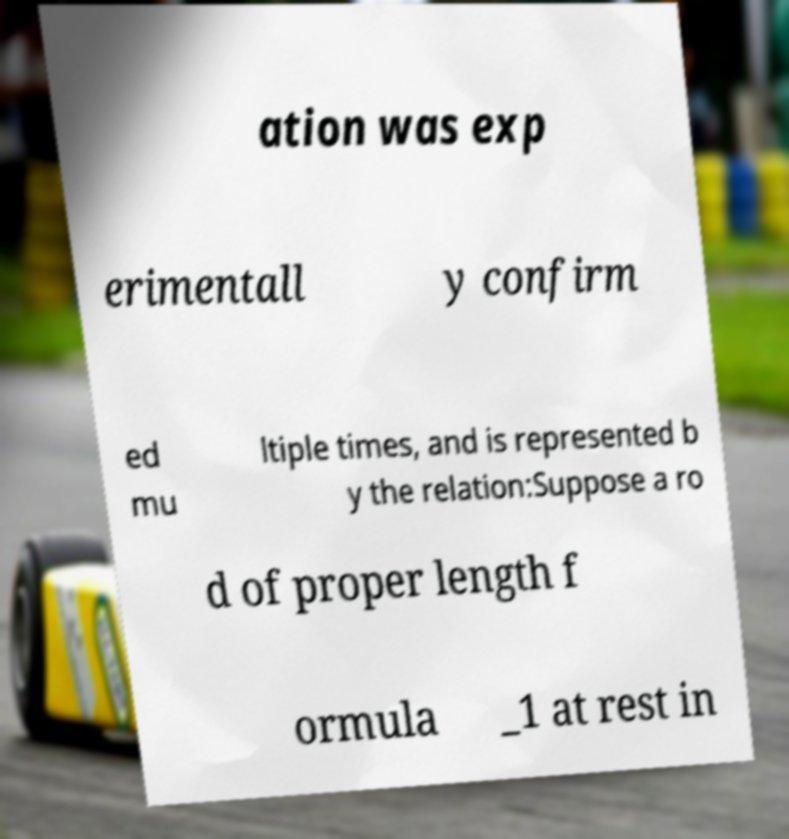Please identify and transcribe the text found in this image. ation was exp erimentall y confirm ed mu ltiple times, and is represented b y the relation:Suppose a ro d of proper length f ormula _1 at rest in 